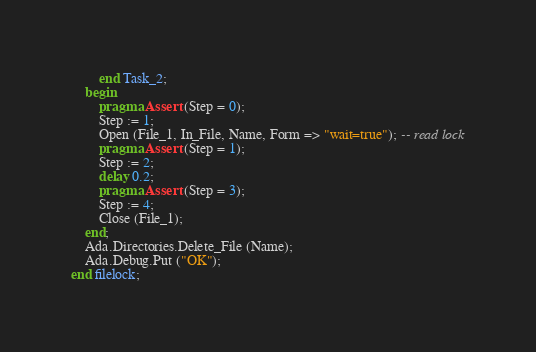<code> <loc_0><loc_0><loc_500><loc_500><_Ada_>		end Task_2;
	begin
		pragma Assert (Step = 0);
		Step := 1;
		Open (File_1, In_File, Name, Form => "wait=true"); -- read lock
		pragma Assert (Step = 1);
		Step := 2;
		delay 0.2;
		pragma Assert (Step = 3);
		Step := 4;
		Close (File_1);
	end;
	Ada.Directories.Delete_File (Name);
	Ada.Debug.Put ("OK");
end filelock;
</code> 